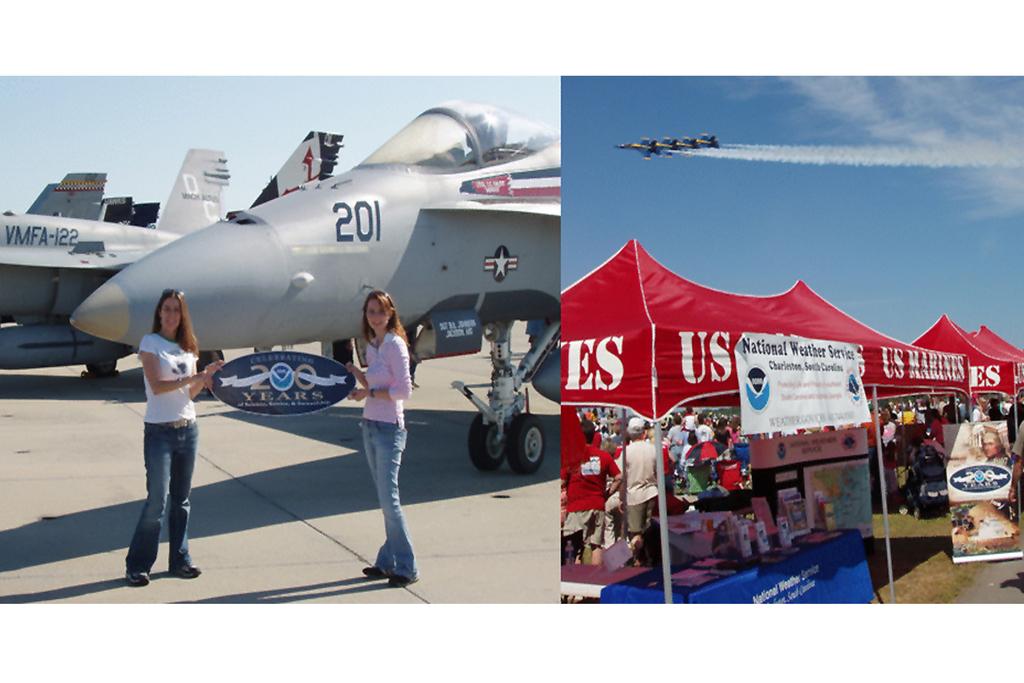What branch of military are the red tents?
Offer a very short reply. Us marines. How many years are the women on the left celebrating?
Provide a short and direct response. 200. 